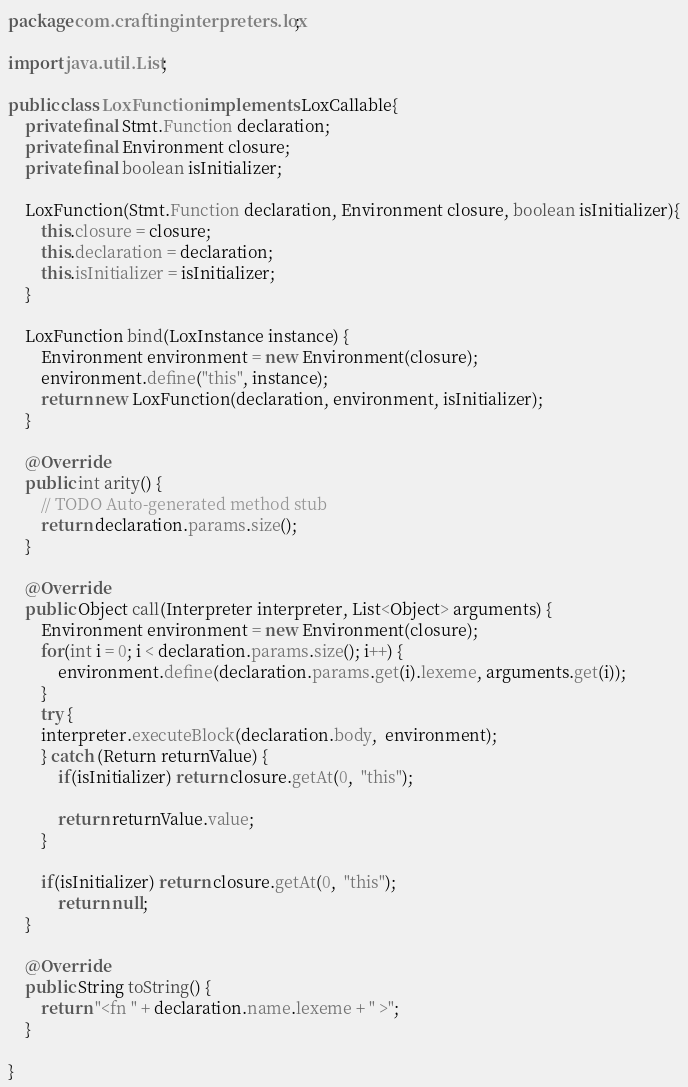<code> <loc_0><loc_0><loc_500><loc_500><_Java_>package com.craftinginterpreters.lox;

import java.util.List;

public class LoxFunction implements LoxCallable{
	private final Stmt.Function declaration;
	private final Environment closure;
	private final boolean isInitializer;
	
	LoxFunction(Stmt.Function declaration, Environment closure, boolean isInitializer){
		this.closure = closure;
		this.declaration = declaration;
		this.isInitializer = isInitializer;
	}
	
	LoxFunction bind(LoxInstance instance) {
		Environment environment = new Environment(closure);
		environment.define("this", instance);
		return new LoxFunction(declaration, environment, isInitializer);
	}

	@Override
	public int arity() {
		// TODO Auto-generated method stub
		return declaration.params.size();
	}

	@Override
	public Object call(Interpreter interpreter, List<Object> arguments) {
		Environment environment = new Environment(closure);
		for(int i = 0; i < declaration.params.size(); i++) {
			environment.define(declaration.params.get(i).lexeme, arguments.get(i));
		}
		try {
		interpreter.executeBlock(declaration.body,  environment);
		} catch (Return returnValue) {
			if(isInitializer) return closure.getAt(0,  "this");
			
			return returnValue.value;
		}
		
		if(isInitializer) return closure.getAt(0,  "this");
			return null;
	}
	
	@Override
	public String toString() {
		return "<fn " + declaration.name.lexeme + " >";
	}

}
</code> 